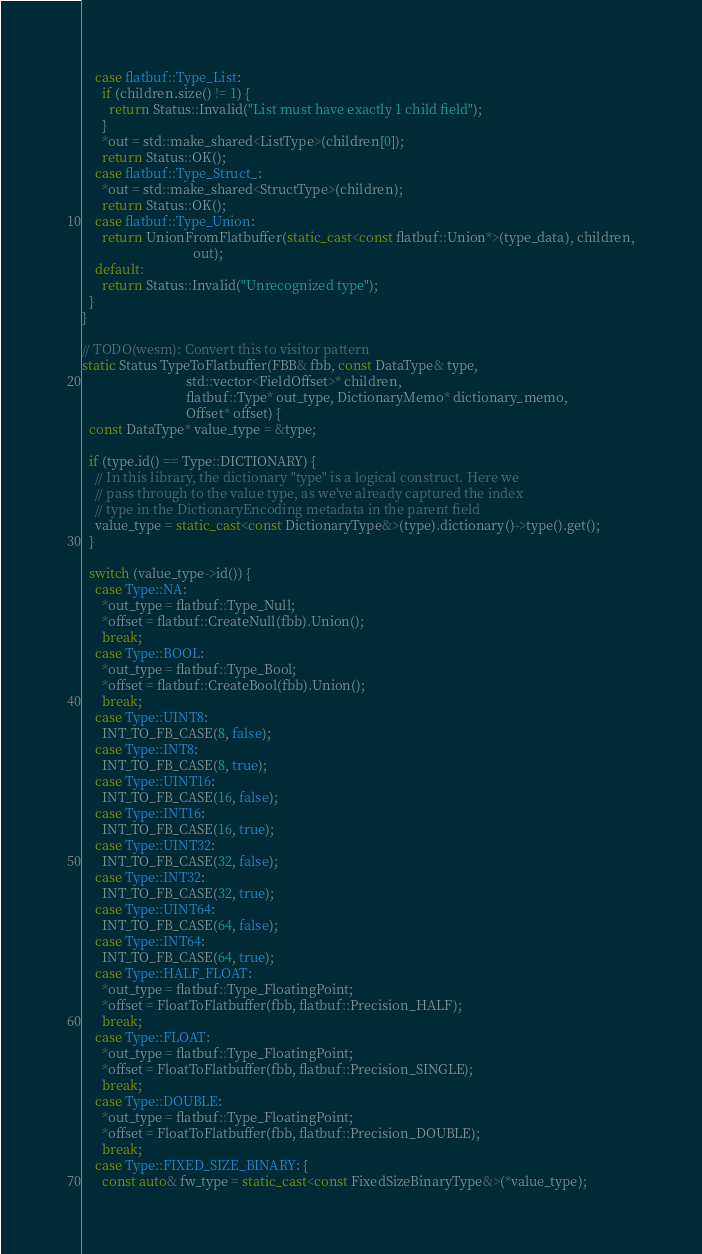Convert code to text. <code><loc_0><loc_0><loc_500><loc_500><_C++_>    case flatbuf::Type_List:
      if (children.size() != 1) {
        return Status::Invalid("List must have exactly 1 child field");
      }
      *out = std::make_shared<ListType>(children[0]);
      return Status::OK();
    case flatbuf::Type_Struct_:
      *out = std::make_shared<StructType>(children);
      return Status::OK();
    case flatbuf::Type_Union:
      return UnionFromFlatbuffer(static_cast<const flatbuf::Union*>(type_data), children,
                                 out);
    default:
      return Status::Invalid("Unrecognized type");
  }
}

// TODO(wesm): Convert this to visitor pattern
static Status TypeToFlatbuffer(FBB& fbb, const DataType& type,
                               std::vector<FieldOffset>* children,
                               flatbuf::Type* out_type, DictionaryMemo* dictionary_memo,
                               Offset* offset) {
  const DataType* value_type = &type;

  if (type.id() == Type::DICTIONARY) {
    // In this library, the dictionary "type" is a logical construct. Here we
    // pass through to the value type, as we've already captured the index
    // type in the DictionaryEncoding metadata in the parent field
    value_type = static_cast<const DictionaryType&>(type).dictionary()->type().get();
  }

  switch (value_type->id()) {
    case Type::NA:
      *out_type = flatbuf::Type_Null;
      *offset = flatbuf::CreateNull(fbb).Union();
      break;
    case Type::BOOL:
      *out_type = flatbuf::Type_Bool;
      *offset = flatbuf::CreateBool(fbb).Union();
      break;
    case Type::UINT8:
      INT_TO_FB_CASE(8, false);
    case Type::INT8:
      INT_TO_FB_CASE(8, true);
    case Type::UINT16:
      INT_TO_FB_CASE(16, false);
    case Type::INT16:
      INT_TO_FB_CASE(16, true);
    case Type::UINT32:
      INT_TO_FB_CASE(32, false);
    case Type::INT32:
      INT_TO_FB_CASE(32, true);
    case Type::UINT64:
      INT_TO_FB_CASE(64, false);
    case Type::INT64:
      INT_TO_FB_CASE(64, true);
    case Type::HALF_FLOAT:
      *out_type = flatbuf::Type_FloatingPoint;
      *offset = FloatToFlatbuffer(fbb, flatbuf::Precision_HALF);
      break;
    case Type::FLOAT:
      *out_type = flatbuf::Type_FloatingPoint;
      *offset = FloatToFlatbuffer(fbb, flatbuf::Precision_SINGLE);
      break;
    case Type::DOUBLE:
      *out_type = flatbuf::Type_FloatingPoint;
      *offset = FloatToFlatbuffer(fbb, flatbuf::Precision_DOUBLE);
      break;
    case Type::FIXED_SIZE_BINARY: {
      const auto& fw_type = static_cast<const FixedSizeBinaryType&>(*value_type);</code> 